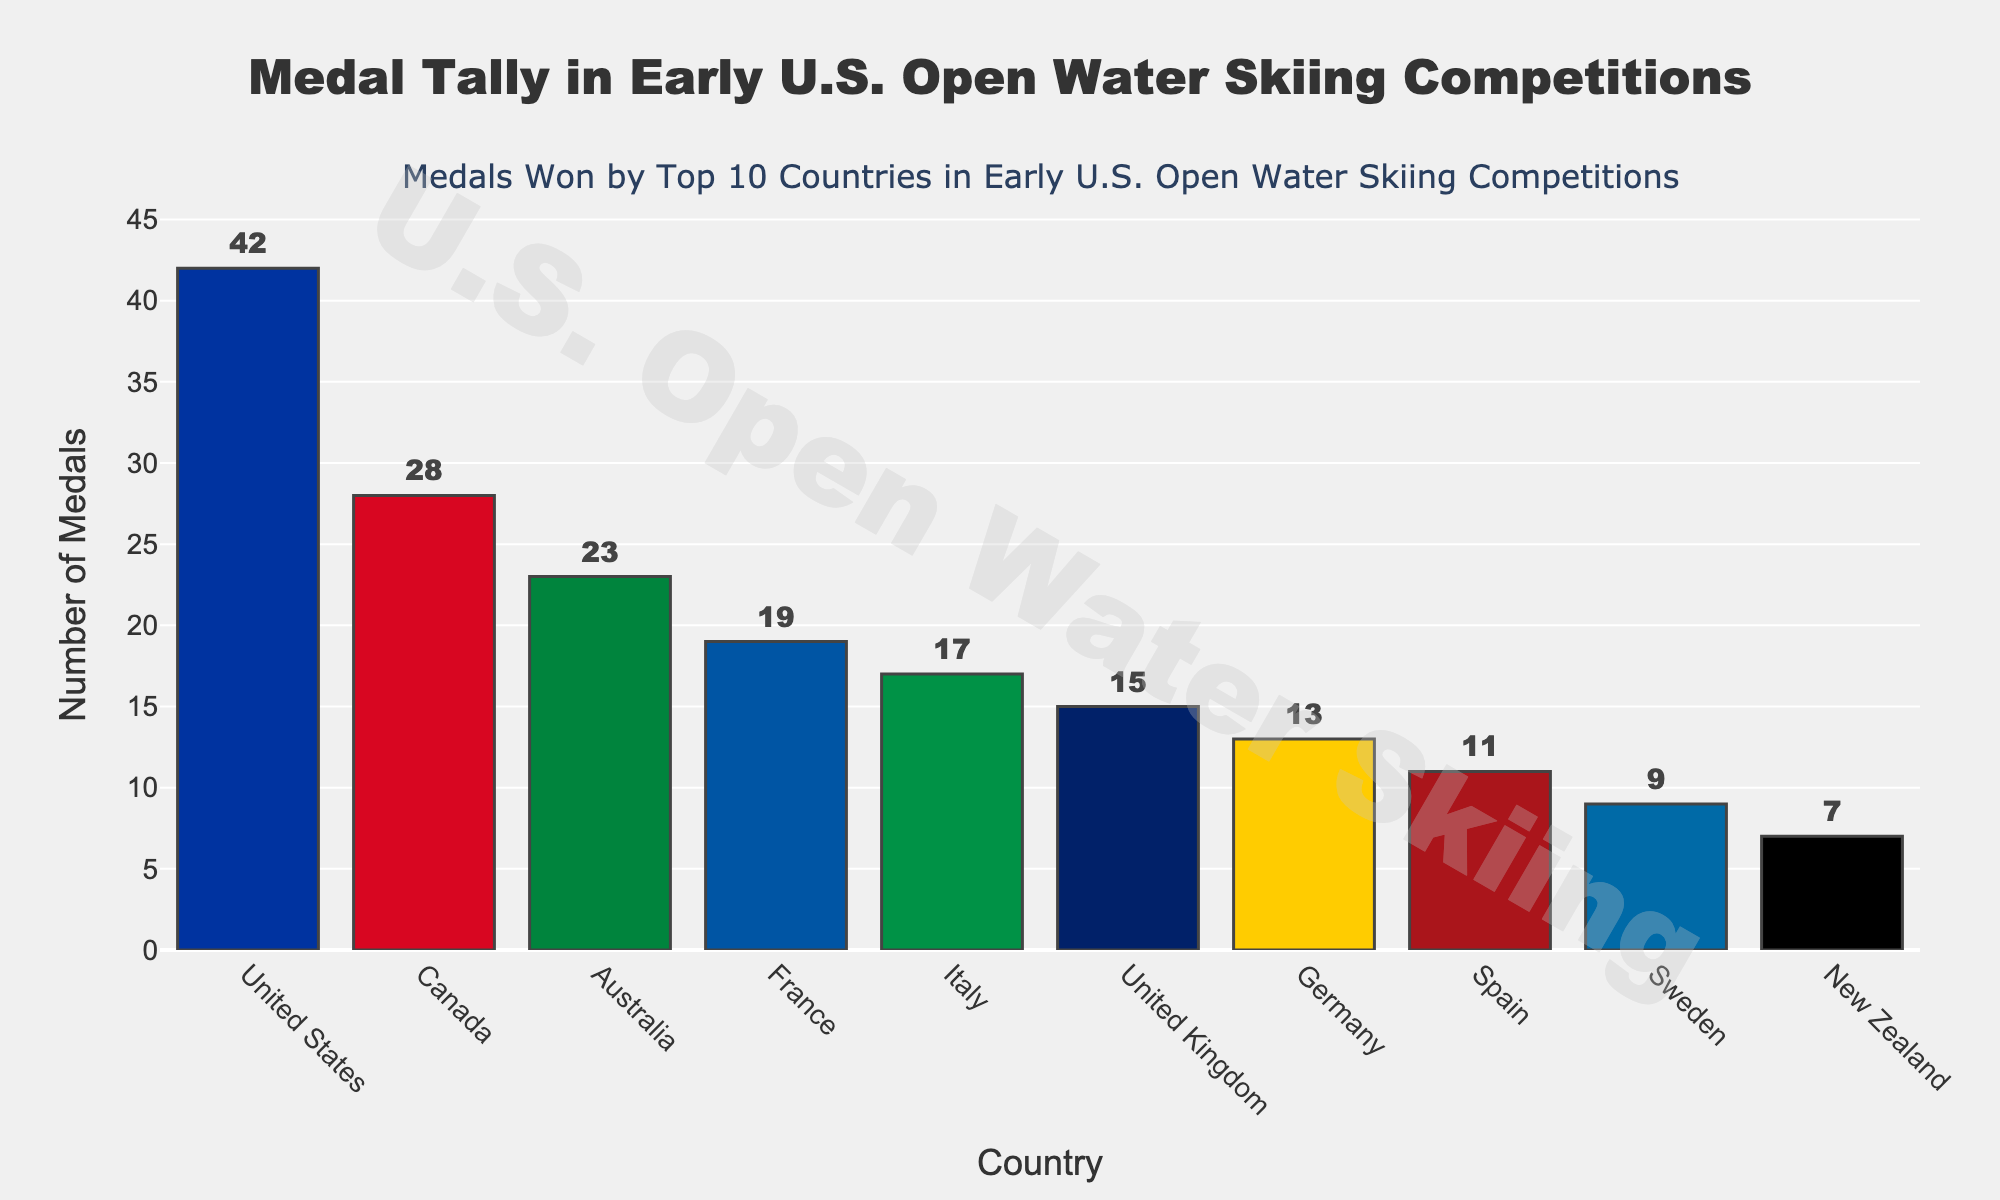Which country has won the most medals? The bar representing the United States is the tallest, and the hover info confirms that the United States won 42 medals.
Answer: United States Which two countries have won the least number of medals among the top 10? The shortest bars represent New Zealand and Sweden, confirmed by hovering to see New Zealand with 7 medals and Sweden with 9 medals.
Answer: New Zealand and Sweden How many more medals has Canada won compared to Germany? Canada has 28 medals, and Germany has 13. The difference is 28 - 13 = 15.
Answer: 15 What is the average number of medals won by the top 10 countries? Sum up the medals (42+28+23+19+17+15+13+11+9+7=184) and divide by the number of countries (10). So, 184 / 10 = 18.4.
Answer: 18.4 How many medals do France and Italy have combined? France has 19 medals and Italy has 17 medals. The sum is 19 + 17 = 36.
Answer: 36 Which country has a bar color that is closest to blue? The bar for Sweden appears closest to blue in color.
Answer: Sweden Is the number of medals won by Australia more than the number won by France and Italy combined? Australia has 23 medals, while France and Italy together have 19 + 17 = 36 medals. 23 < 36, so Australia has fewer medals.
Answer: No How many countries have won more than 20 medals? By counting the bars with heights greater than 20, we find the United States (42), Canada (28), and Australia (23).
Answer: 3 Which countries have won more medals: Italy or United Kingdom and Germany combined? Italy has 17 medals; United Kingdom and Germany together have 15 + 13 = 28 medals. 17 < 28.
Answer: United Kingdom and Germany What is the difference in the number of medals between the country with the most medals and the country with the second most medals? The United States has 42 medals, and Canada has 28. The difference is 42 - 28 = 14.
Answer: 14 